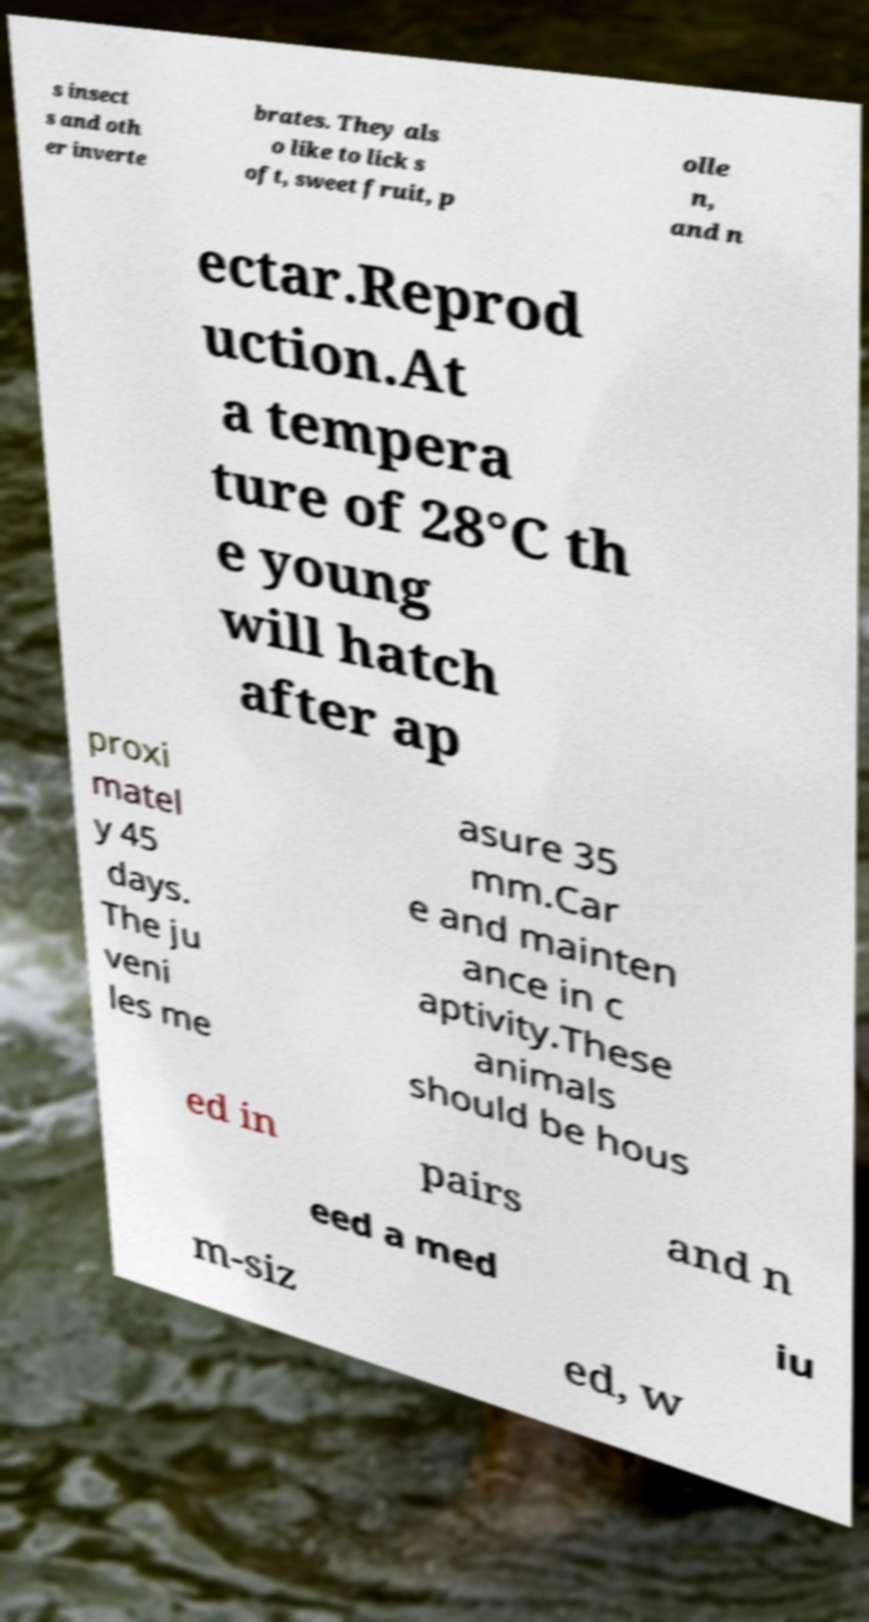Please read and relay the text visible in this image. What does it say? s insect s and oth er inverte brates. They als o like to lick s oft, sweet fruit, p olle n, and n ectar.Reprod uction.At a tempera ture of 28°C th e young will hatch after ap proxi matel y 45 days. The ju veni les me asure 35 mm.Car e and mainten ance in c aptivity.These animals should be hous ed in pairs and n eed a med iu m-siz ed, w 